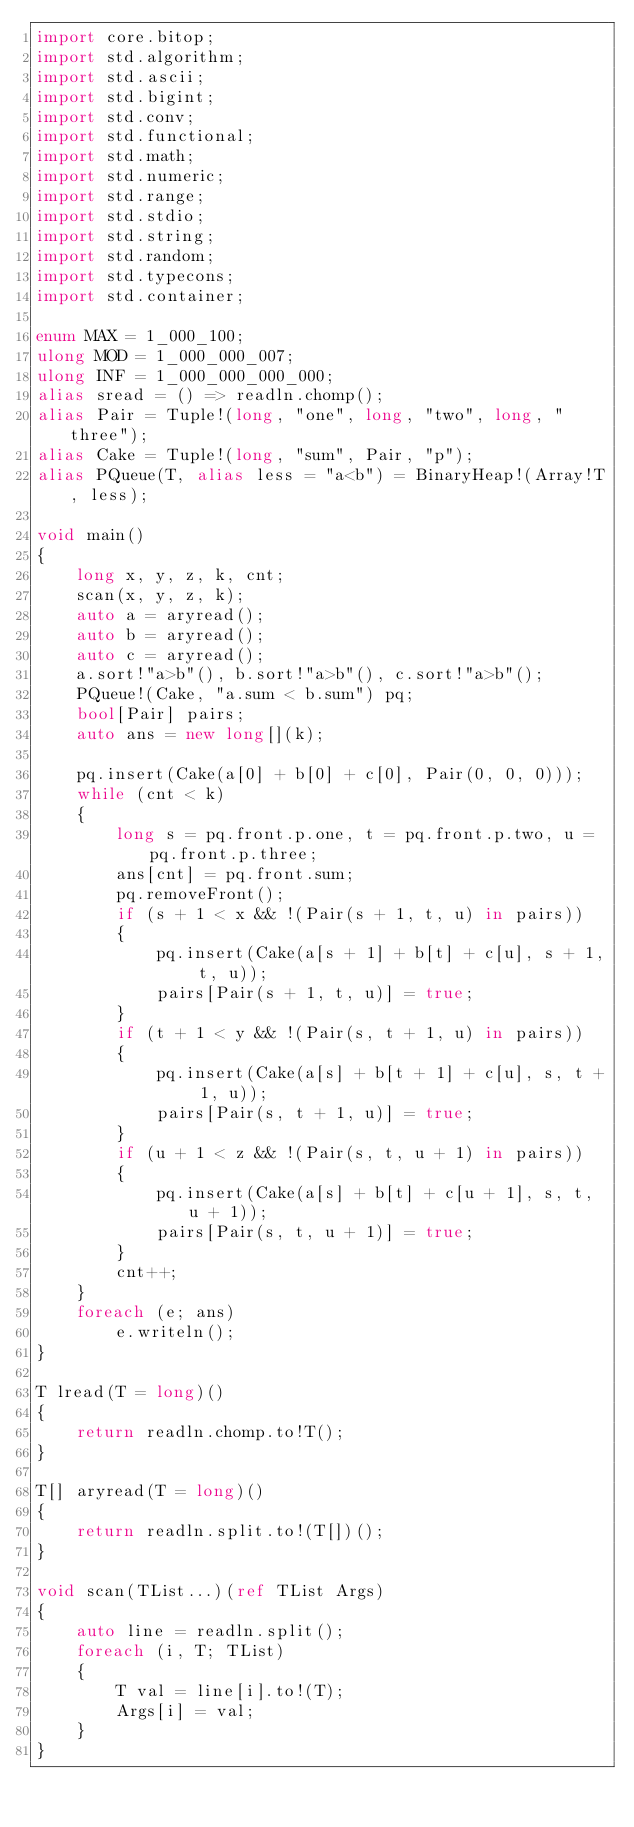Convert code to text. <code><loc_0><loc_0><loc_500><loc_500><_D_>import core.bitop;
import std.algorithm;
import std.ascii;
import std.bigint;
import std.conv;
import std.functional;
import std.math;
import std.numeric;
import std.range;
import std.stdio;
import std.string;
import std.random;
import std.typecons;
import std.container;

enum MAX = 1_000_100;
ulong MOD = 1_000_000_007;
ulong INF = 1_000_000_000_000;
alias sread = () => readln.chomp();
alias Pair = Tuple!(long, "one", long, "two", long, "three");
alias Cake = Tuple!(long, "sum", Pair, "p");
alias PQueue(T, alias less = "a<b") = BinaryHeap!(Array!T, less);

void main()
{
    long x, y, z, k, cnt;
    scan(x, y, z, k);
    auto a = aryread();
    auto b = aryread();
    auto c = aryread();
    a.sort!"a>b"(), b.sort!"a>b"(), c.sort!"a>b"();
    PQueue!(Cake, "a.sum < b.sum") pq;
    bool[Pair] pairs;
    auto ans = new long[](k);

    pq.insert(Cake(a[0] + b[0] + c[0], Pair(0, 0, 0)));
    while (cnt < k)
    {
        long s = pq.front.p.one, t = pq.front.p.two, u = pq.front.p.three;
        ans[cnt] = pq.front.sum;
        pq.removeFront();
        if (s + 1 < x && !(Pair(s + 1, t, u) in pairs))
        {
            pq.insert(Cake(a[s + 1] + b[t] + c[u], s + 1, t, u));
            pairs[Pair(s + 1, t, u)] = true;
        }
        if (t + 1 < y && !(Pair(s, t + 1, u) in pairs))
        {
            pq.insert(Cake(a[s] + b[t + 1] + c[u], s, t + 1, u));
            pairs[Pair(s, t + 1, u)] = true;
        }
        if (u + 1 < z && !(Pair(s, t, u + 1) in pairs))
        {
            pq.insert(Cake(a[s] + b[t] + c[u + 1], s, t, u + 1));
            pairs[Pair(s, t, u + 1)] = true;
        }
        cnt++;
    }
    foreach (e; ans)
        e.writeln();
}

T lread(T = long)()
{
    return readln.chomp.to!T();
}

T[] aryread(T = long)()
{
    return readln.split.to!(T[])();
}

void scan(TList...)(ref TList Args)
{
    auto line = readln.split();
    foreach (i, T; TList)
    {
        T val = line[i].to!(T);
        Args[i] = val;
    }
}
</code> 